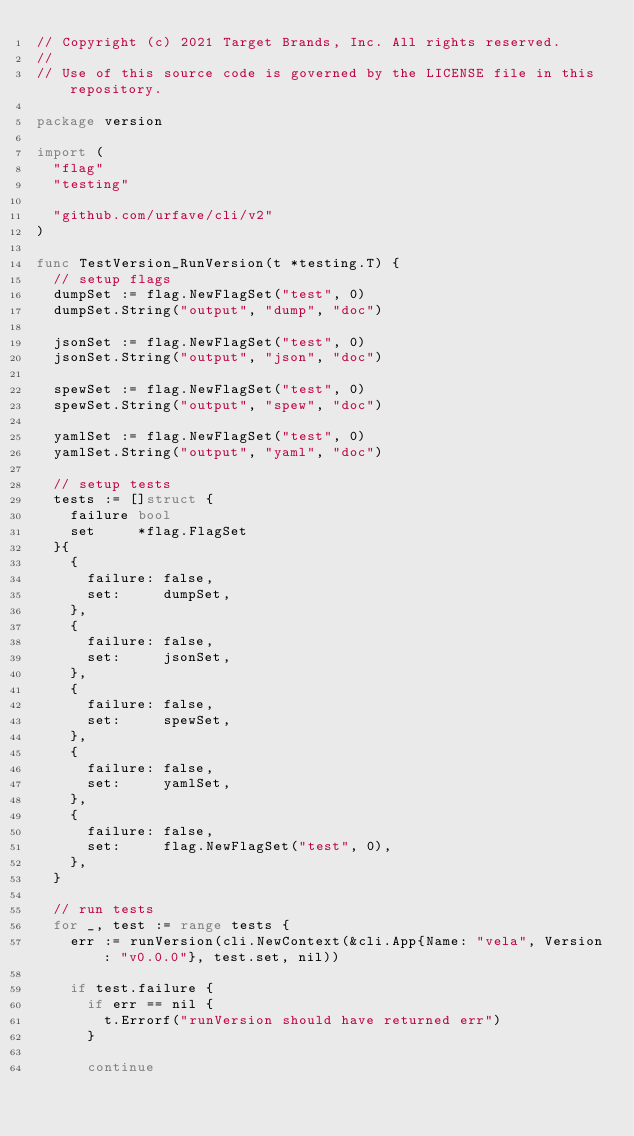<code> <loc_0><loc_0><loc_500><loc_500><_Go_>// Copyright (c) 2021 Target Brands, Inc. All rights reserved.
//
// Use of this source code is governed by the LICENSE file in this repository.

package version

import (
	"flag"
	"testing"

	"github.com/urfave/cli/v2"
)

func TestVersion_RunVersion(t *testing.T) {
	// setup flags
	dumpSet := flag.NewFlagSet("test", 0)
	dumpSet.String("output", "dump", "doc")

	jsonSet := flag.NewFlagSet("test", 0)
	jsonSet.String("output", "json", "doc")

	spewSet := flag.NewFlagSet("test", 0)
	spewSet.String("output", "spew", "doc")

	yamlSet := flag.NewFlagSet("test", 0)
	yamlSet.String("output", "yaml", "doc")

	// setup tests
	tests := []struct {
		failure bool
		set     *flag.FlagSet
	}{
		{
			failure: false,
			set:     dumpSet,
		},
		{
			failure: false,
			set:     jsonSet,
		},
		{
			failure: false,
			set:     spewSet,
		},
		{
			failure: false,
			set:     yamlSet,
		},
		{
			failure: false,
			set:     flag.NewFlagSet("test", 0),
		},
	}

	// run tests
	for _, test := range tests {
		err := runVersion(cli.NewContext(&cli.App{Name: "vela", Version: "v0.0.0"}, test.set, nil))

		if test.failure {
			if err == nil {
				t.Errorf("runVersion should have returned err")
			}

			continue</code> 